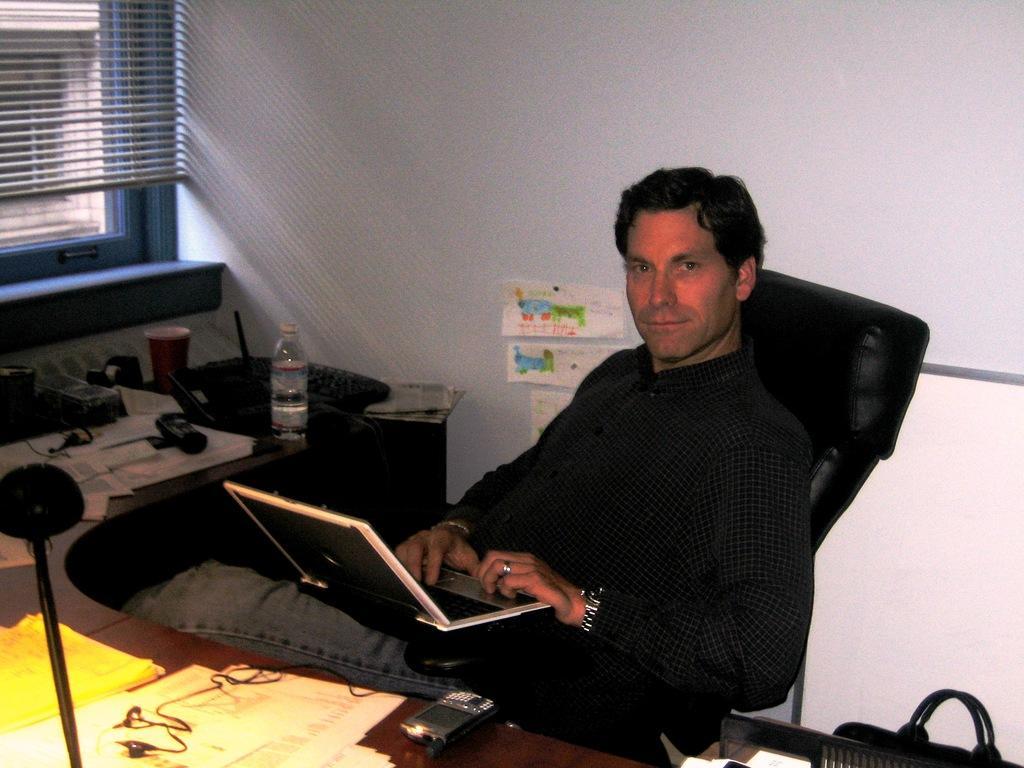How would you summarize this image in a sentence or two? in this image there is a man sitting on a chair, operating his laptop. there is a desk in front of him , it contains lots of papers, a glass and a water bottle. in the left corner of the image there is a window. 